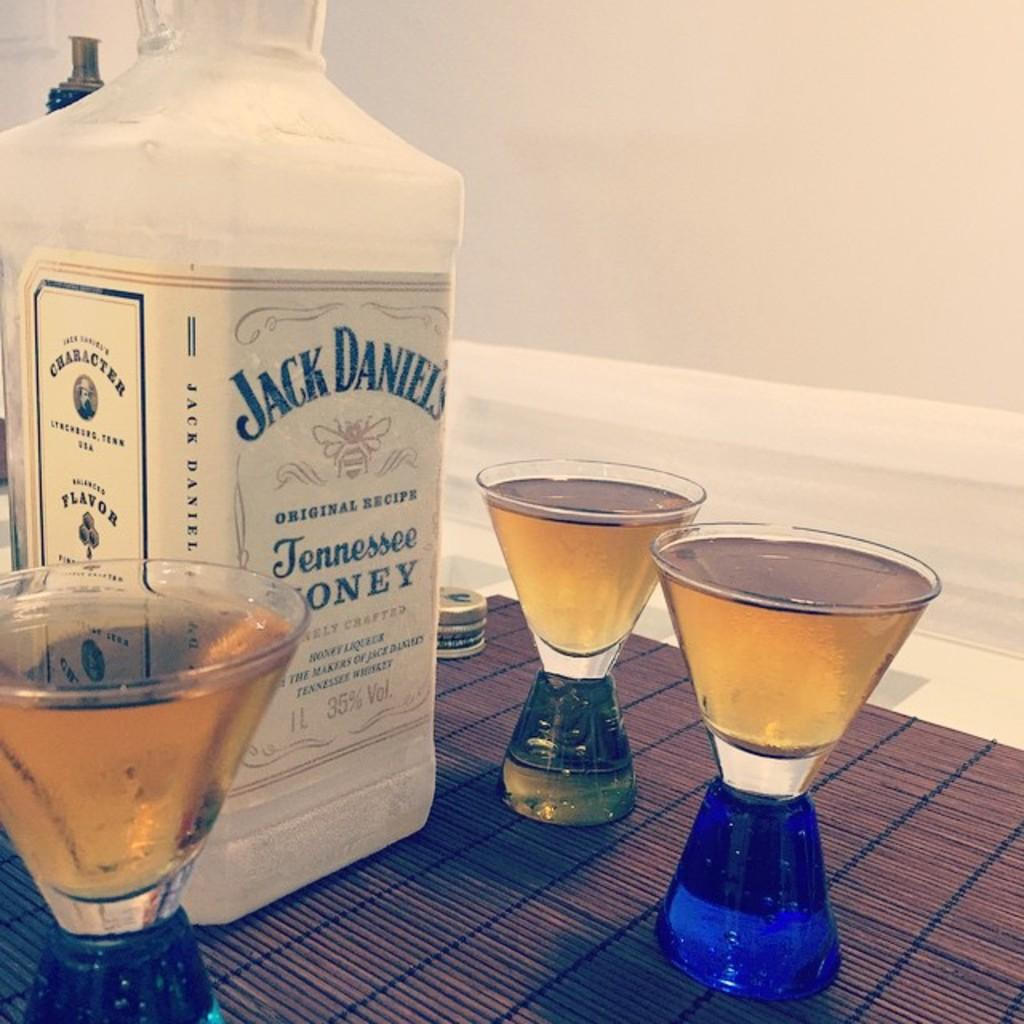<image>
Write a terse but informative summary of the picture. A white bottle has a label for Jack Daniels. 